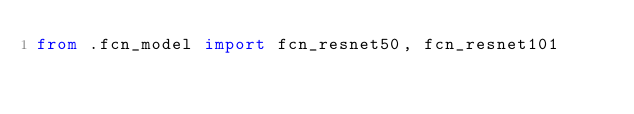Convert code to text. <code><loc_0><loc_0><loc_500><loc_500><_Python_>from .fcn_model import fcn_resnet50, fcn_resnet101
</code> 